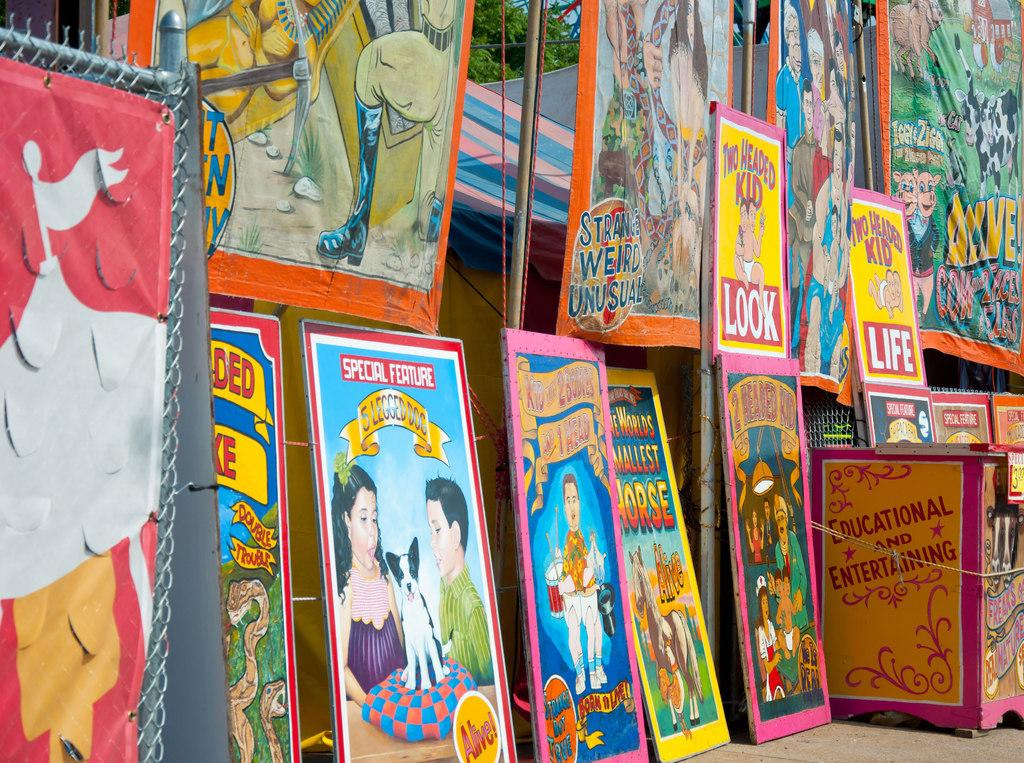Provide a one-sentence caption for the provided image. a collection of books with one being a special edition 5 leg dog book. 